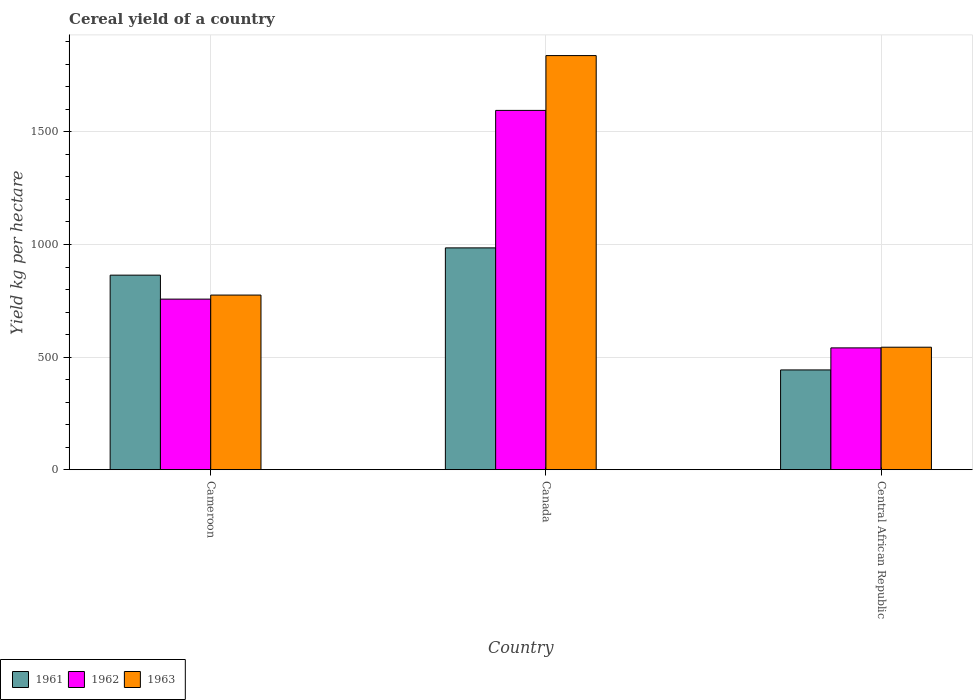How many different coloured bars are there?
Ensure brevity in your answer.  3. How many groups of bars are there?
Keep it short and to the point. 3. How many bars are there on the 3rd tick from the right?
Give a very brief answer. 3. What is the label of the 1st group of bars from the left?
Your answer should be compact. Cameroon. What is the total cereal yield in 1963 in Cameroon?
Make the answer very short. 775.43. Across all countries, what is the maximum total cereal yield in 1961?
Provide a succinct answer. 984.99. Across all countries, what is the minimum total cereal yield in 1962?
Offer a very short reply. 540.91. In which country was the total cereal yield in 1962 maximum?
Offer a terse response. Canada. In which country was the total cereal yield in 1961 minimum?
Ensure brevity in your answer.  Central African Republic. What is the total total cereal yield in 1961 in the graph?
Your response must be concise. 2291.86. What is the difference between the total cereal yield in 1961 in Cameroon and that in Central African Republic?
Offer a terse response. 420.88. What is the difference between the total cereal yield in 1963 in Cameroon and the total cereal yield in 1961 in Central African Republic?
Make the answer very short. 332.43. What is the average total cereal yield in 1963 per country?
Your answer should be very brief. 1052.72. What is the difference between the total cereal yield of/in 1961 and total cereal yield of/in 1962 in Cameroon?
Give a very brief answer. 106.42. In how many countries, is the total cereal yield in 1961 greater than 1700 kg per hectare?
Make the answer very short. 0. What is the ratio of the total cereal yield in 1961 in Canada to that in Central African Republic?
Offer a terse response. 2.22. Is the difference between the total cereal yield in 1961 in Cameroon and Canada greater than the difference between the total cereal yield in 1962 in Cameroon and Canada?
Provide a succinct answer. Yes. What is the difference between the highest and the second highest total cereal yield in 1963?
Offer a very short reply. -1294.99. What is the difference between the highest and the lowest total cereal yield in 1963?
Your answer should be compact. 1294.99. What does the 3rd bar from the left in Central African Republic represents?
Your response must be concise. 1963. How many bars are there?
Provide a short and direct response. 9. Are all the bars in the graph horizontal?
Provide a short and direct response. No. Are the values on the major ticks of Y-axis written in scientific E-notation?
Make the answer very short. No. What is the title of the graph?
Offer a very short reply. Cereal yield of a country. What is the label or title of the X-axis?
Your answer should be compact. Country. What is the label or title of the Y-axis?
Your answer should be compact. Yield kg per hectare. What is the Yield kg per hectare in 1961 in Cameroon?
Provide a succinct answer. 863.87. What is the Yield kg per hectare in 1962 in Cameroon?
Keep it short and to the point. 757.46. What is the Yield kg per hectare of 1963 in Cameroon?
Your response must be concise. 775.43. What is the Yield kg per hectare in 1961 in Canada?
Your answer should be very brief. 984.99. What is the Yield kg per hectare of 1962 in Canada?
Ensure brevity in your answer.  1595.42. What is the Yield kg per hectare in 1963 in Canada?
Your response must be concise. 1838.86. What is the Yield kg per hectare in 1961 in Central African Republic?
Your answer should be compact. 443. What is the Yield kg per hectare of 1962 in Central African Republic?
Keep it short and to the point. 540.91. What is the Yield kg per hectare of 1963 in Central African Republic?
Provide a short and direct response. 543.87. Across all countries, what is the maximum Yield kg per hectare of 1961?
Make the answer very short. 984.99. Across all countries, what is the maximum Yield kg per hectare of 1962?
Your response must be concise. 1595.42. Across all countries, what is the maximum Yield kg per hectare in 1963?
Provide a short and direct response. 1838.86. Across all countries, what is the minimum Yield kg per hectare of 1961?
Keep it short and to the point. 443. Across all countries, what is the minimum Yield kg per hectare in 1962?
Offer a very short reply. 540.91. Across all countries, what is the minimum Yield kg per hectare in 1963?
Offer a terse response. 543.87. What is the total Yield kg per hectare in 1961 in the graph?
Provide a succinct answer. 2291.86. What is the total Yield kg per hectare of 1962 in the graph?
Provide a short and direct response. 2893.78. What is the total Yield kg per hectare of 1963 in the graph?
Provide a short and direct response. 3158.16. What is the difference between the Yield kg per hectare of 1961 in Cameroon and that in Canada?
Your answer should be compact. -121.12. What is the difference between the Yield kg per hectare of 1962 in Cameroon and that in Canada?
Ensure brevity in your answer.  -837.96. What is the difference between the Yield kg per hectare of 1963 in Cameroon and that in Canada?
Provide a succinct answer. -1063.44. What is the difference between the Yield kg per hectare of 1961 in Cameroon and that in Central African Republic?
Offer a very short reply. 420.88. What is the difference between the Yield kg per hectare in 1962 in Cameroon and that in Central African Republic?
Your answer should be very brief. 216.55. What is the difference between the Yield kg per hectare of 1963 in Cameroon and that in Central African Republic?
Offer a terse response. 231.56. What is the difference between the Yield kg per hectare in 1961 in Canada and that in Central African Republic?
Make the answer very short. 541.99. What is the difference between the Yield kg per hectare of 1962 in Canada and that in Central African Republic?
Ensure brevity in your answer.  1054.51. What is the difference between the Yield kg per hectare in 1963 in Canada and that in Central African Republic?
Ensure brevity in your answer.  1294.99. What is the difference between the Yield kg per hectare of 1961 in Cameroon and the Yield kg per hectare of 1962 in Canada?
Keep it short and to the point. -731.54. What is the difference between the Yield kg per hectare of 1961 in Cameroon and the Yield kg per hectare of 1963 in Canada?
Make the answer very short. -974.99. What is the difference between the Yield kg per hectare in 1962 in Cameroon and the Yield kg per hectare in 1963 in Canada?
Keep it short and to the point. -1081.41. What is the difference between the Yield kg per hectare in 1961 in Cameroon and the Yield kg per hectare in 1962 in Central African Republic?
Keep it short and to the point. 322.96. What is the difference between the Yield kg per hectare in 1961 in Cameroon and the Yield kg per hectare in 1963 in Central African Republic?
Keep it short and to the point. 320. What is the difference between the Yield kg per hectare in 1962 in Cameroon and the Yield kg per hectare in 1963 in Central African Republic?
Offer a very short reply. 213.58. What is the difference between the Yield kg per hectare in 1961 in Canada and the Yield kg per hectare in 1962 in Central African Republic?
Provide a short and direct response. 444.08. What is the difference between the Yield kg per hectare of 1961 in Canada and the Yield kg per hectare of 1963 in Central African Republic?
Give a very brief answer. 441.12. What is the difference between the Yield kg per hectare of 1962 in Canada and the Yield kg per hectare of 1963 in Central African Republic?
Offer a very short reply. 1051.55. What is the average Yield kg per hectare of 1961 per country?
Your answer should be very brief. 763.95. What is the average Yield kg per hectare of 1962 per country?
Your answer should be compact. 964.59. What is the average Yield kg per hectare in 1963 per country?
Provide a short and direct response. 1052.72. What is the difference between the Yield kg per hectare in 1961 and Yield kg per hectare in 1962 in Cameroon?
Your response must be concise. 106.42. What is the difference between the Yield kg per hectare of 1961 and Yield kg per hectare of 1963 in Cameroon?
Offer a very short reply. 88.44. What is the difference between the Yield kg per hectare in 1962 and Yield kg per hectare in 1963 in Cameroon?
Your answer should be compact. -17.97. What is the difference between the Yield kg per hectare of 1961 and Yield kg per hectare of 1962 in Canada?
Your response must be concise. -610.43. What is the difference between the Yield kg per hectare of 1961 and Yield kg per hectare of 1963 in Canada?
Offer a terse response. -853.88. What is the difference between the Yield kg per hectare in 1962 and Yield kg per hectare in 1963 in Canada?
Ensure brevity in your answer.  -243.45. What is the difference between the Yield kg per hectare in 1961 and Yield kg per hectare in 1962 in Central African Republic?
Your answer should be compact. -97.91. What is the difference between the Yield kg per hectare in 1961 and Yield kg per hectare in 1963 in Central African Republic?
Make the answer very short. -100.87. What is the difference between the Yield kg per hectare in 1962 and Yield kg per hectare in 1963 in Central African Republic?
Give a very brief answer. -2.96. What is the ratio of the Yield kg per hectare of 1961 in Cameroon to that in Canada?
Keep it short and to the point. 0.88. What is the ratio of the Yield kg per hectare in 1962 in Cameroon to that in Canada?
Give a very brief answer. 0.47. What is the ratio of the Yield kg per hectare of 1963 in Cameroon to that in Canada?
Make the answer very short. 0.42. What is the ratio of the Yield kg per hectare of 1961 in Cameroon to that in Central African Republic?
Give a very brief answer. 1.95. What is the ratio of the Yield kg per hectare in 1962 in Cameroon to that in Central African Republic?
Provide a short and direct response. 1.4. What is the ratio of the Yield kg per hectare in 1963 in Cameroon to that in Central African Republic?
Your answer should be very brief. 1.43. What is the ratio of the Yield kg per hectare of 1961 in Canada to that in Central African Republic?
Give a very brief answer. 2.22. What is the ratio of the Yield kg per hectare in 1962 in Canada to that in Central African Republic?
Provide a short and direct response. 2.95. What is the ratio of the Yield kg per hectare of 1963 in Canada to that in Central African Republic?
Your answer should be very brief. 3.38. What is the difference between the highest and the second highest Yield kg per hectare in 1961?
Your response must be concise. 121.12. What is the difference between the highest and the second highest Yield kg per hectare in 1962?
Ensure brevity in your answer.  837.96. What is the difference between the highest and the second highest Yield kg per hectare of 1963?
Your response must be concise. 1063.44. What is the difference between the highest and the lowest Yield kg per hectare in 1961?
Your answer should be very brief. 541.99. What is the difference between the highest and the lowest Yield kg per hectare in 1962?
Give a very brief answer. 1054.51. What is the difference between the highest and the lowest Yield kg per hectare of 1963?
Offer a very short reply. 1294.99. 